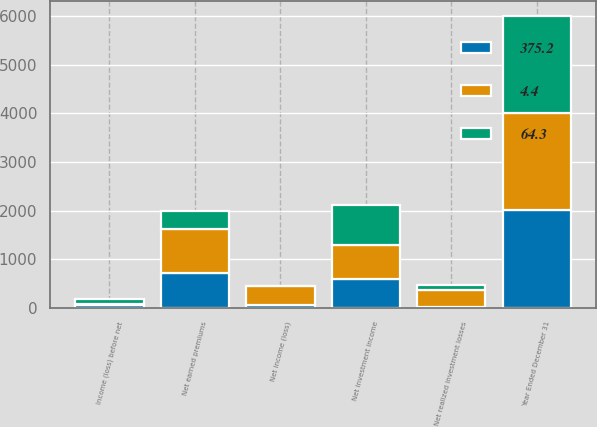Convert chart to OTSL. <chart><loc_0><loc_0><loc_500><loc_500><stacked_bar_chart><ecel><fcel>Year Ended December 31<fcel>Net earned premiums<fcel>Net investment income<fcel>Income (loss) before net<fcel>Net realized investment losses<fcel>Net income (loss)<nl><fcel>375.2<fcel>2005<fcel>704<fcel>593.4<fcel>46.7<fcel>17.6<fcel>64.3<nl><fcel>4.4<fcel>2004<fcel>921<fcel>691.8<fcel>26.2<fcel>349<fcel>375.2<nl><fcel>64.3<fcel>2003<fcel>375.2<fcel>820.6<fcel>102<fcel>97.6<fcel>4.4<nl></chart> 